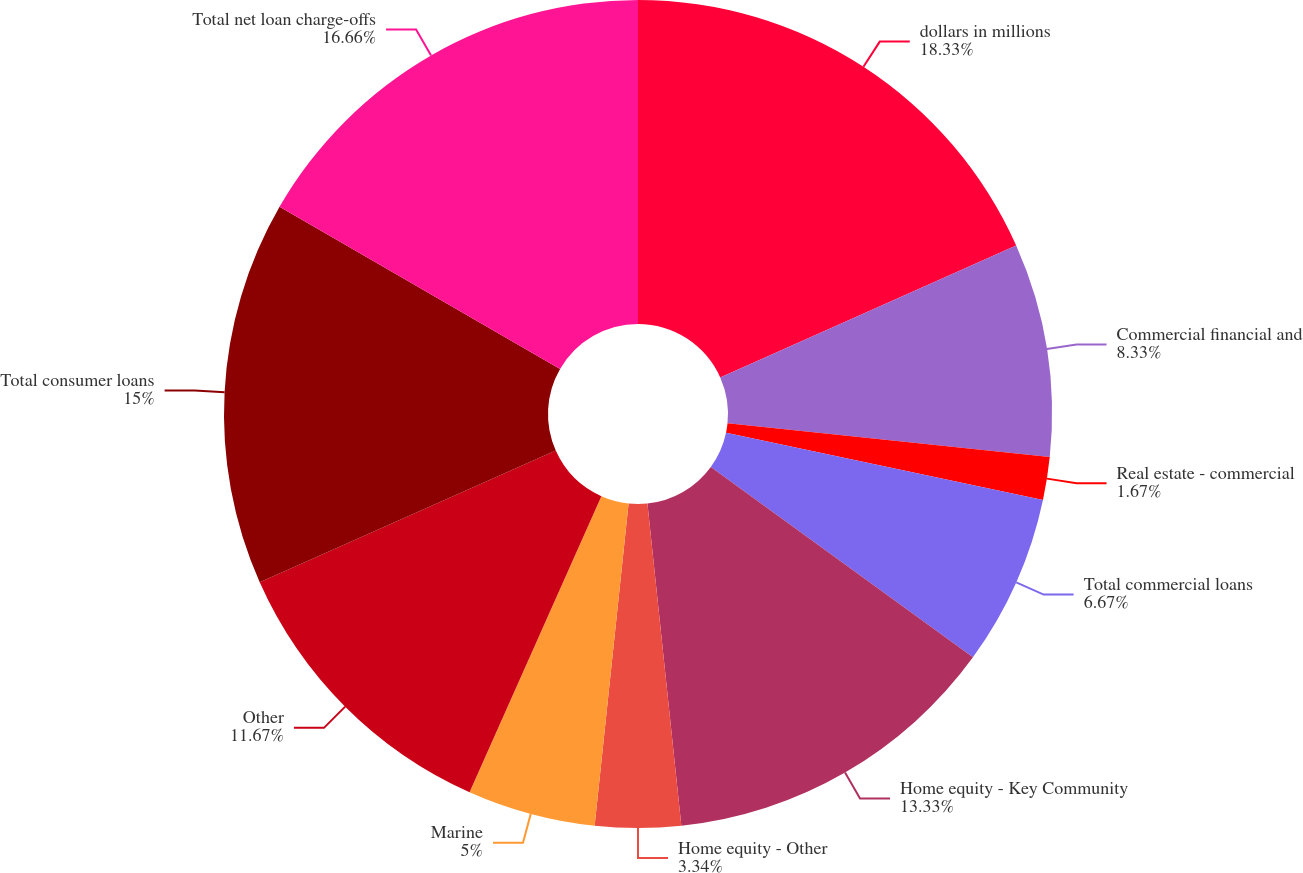<chart> <loc_0><loc_0><loc_500><loc_500><pie_chart><fcel>dollars in millions<fcel>Commercial financial and<fcel>Real estate - commercial<fcel>Total commercial loans<fcel>Home equity - Key Community<fcel>Home equity - Other<fcel>Marine<fcel>Other<fcel>Total consumer loans<fcel>Total net loan charge-offs<nl><fcel>18.33%<fcel>8.33%<fcel>1.67%<fcel>6.67%<fcel>13.33%<fcel>3.34%<fcel>5.0%<fcel>11.67%<fcel>15.0%<fcel>16.66%<nl></chart> 